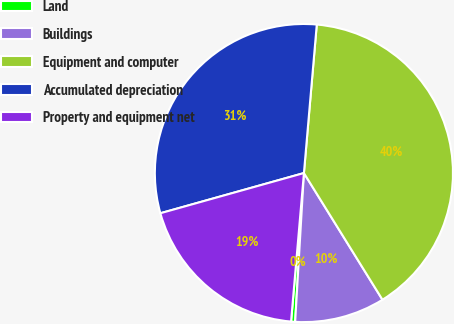<chart> <loc_0><loc_0><loc_500><loc_500><pie_chart><fcel>Land<fcel>Buildings<fcel>Equipment and computer<fcel>Accumulated depreciation<fcel>Property and equipment net<nl><fcel>0.44%<fcel>9.77%<fcel>39.79%<fcel>30.72%<fcel>19.28%<nl></chart> 